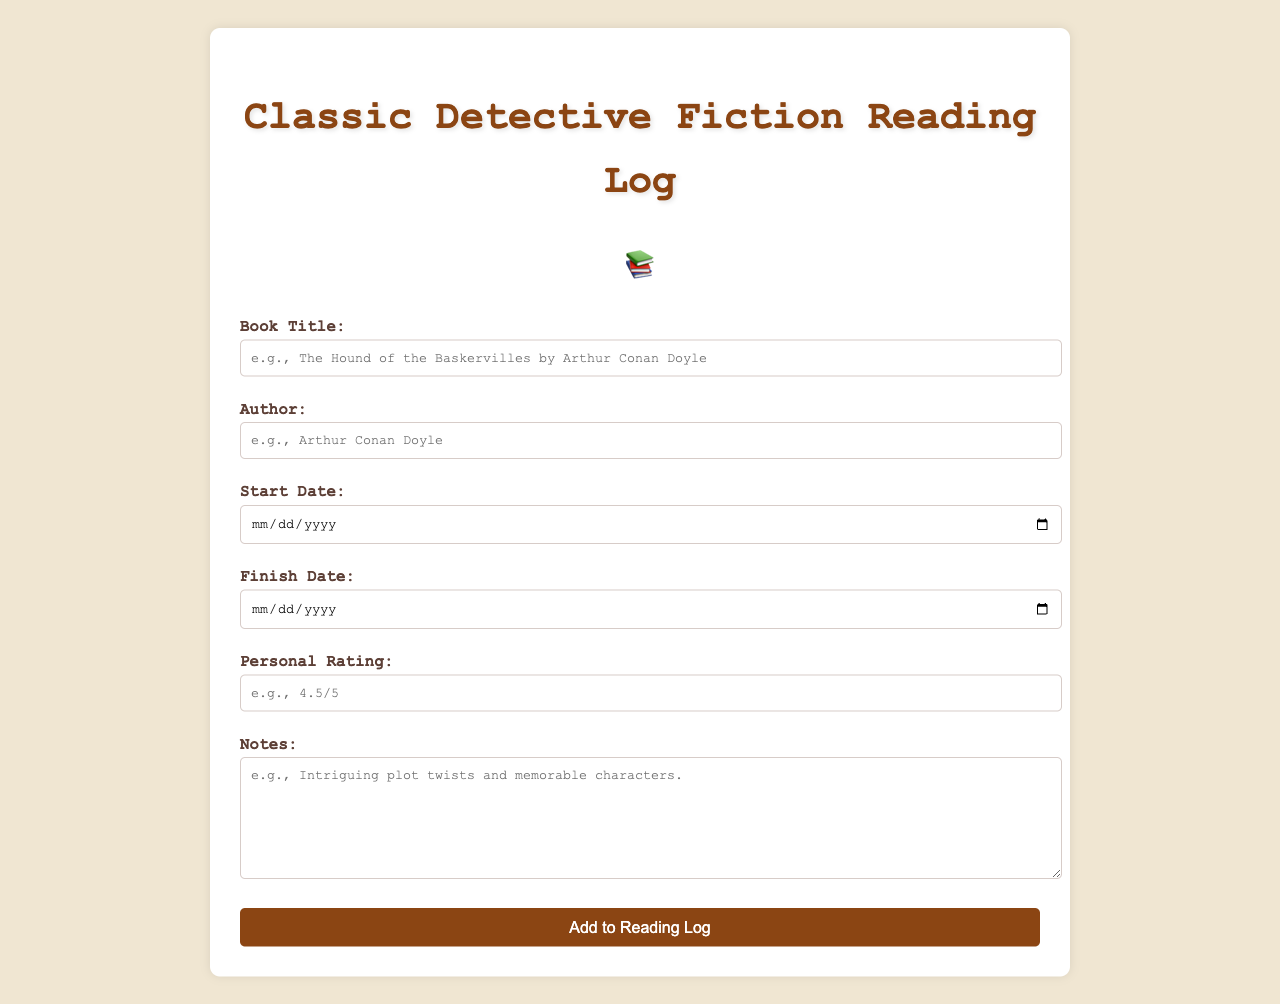What is the title of the form? The title of the form is prominently displayed at the top of the document and identifies the purpose of the reading log.
Answer: Classic Detective Fiction Reading Log Who is the placeholder author example in the input field? The placeholder provides an example name to guide users on how to fill out the author field correctly.
Answer: Arthur Conan Doyle What input is required for the start date? The start date is a necessary field that users must complete before submitting the form, indicating when they began reading the book.
Answer: Required What is the format for personal rating? The personal rating field includes an example to help users understand how to express their evaluation of the book.
Answer: 4.5/5 What is the purpose of the notes field? The notes field is intended for users to provide additional commentary or reflections on their reading experience.
Answer: Additional commentary 